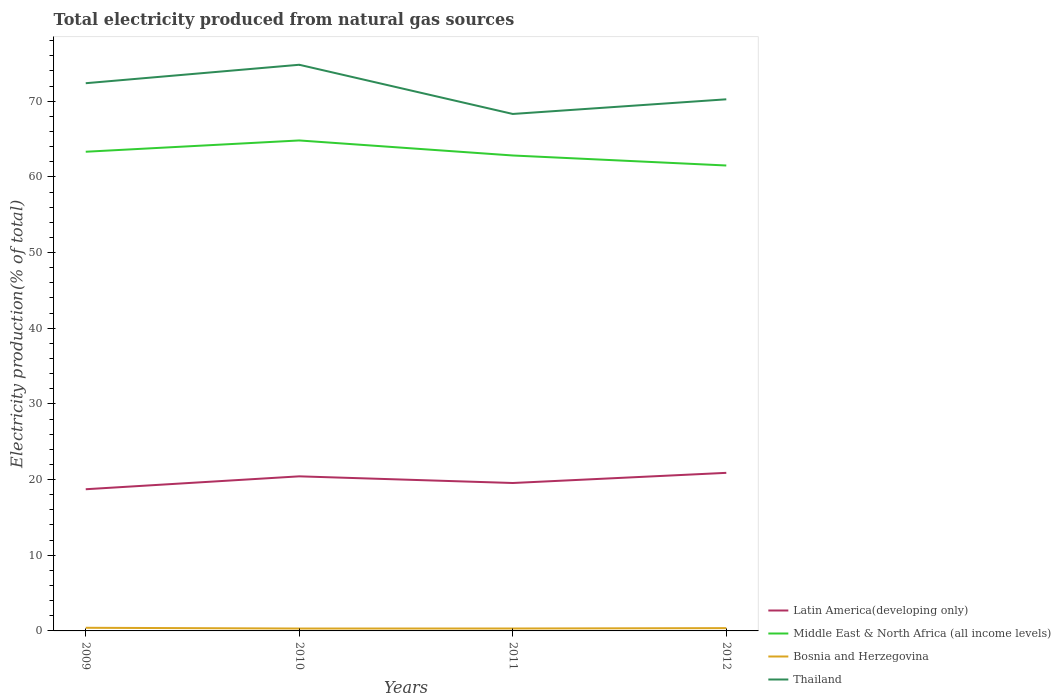How many different coloured lines are there?
Your answer should be compact. 4. Does the line corresponding to Middle East & North Africa (all income levels) intersect with the line corresponding to Latin America(developing only)?
Offer a very short reply. No. Across all years, what is the maximum total electricity produced in Latin America(developing only)?
Your answer should be very brief. 18.72. In which year was the total electricity produced in Bosnia and Herzegovina maximum?
Make the answer very short. 2010. What is the total total electricity produced in Bosnia and Herzegovina in the graph?
Provide a short and direct response. -0.05. What is the difference between the highest and the second highest total electricity produced in Latin America(developing only)?
Provide a short and direct response. 2.17. How many years are there in the graph?
Give a very brief answer. 4. What is the difference between two consecutive major ticks on the Y-axis?
Offer a very short reply. 10. Are the values on the major ticks of Y-axis written in scientific E-notation?
Keep it short and to the point. No. What is the title of the graph?
Provide a short and direct response. Total electricity produced from natural gas sources. What is the label or title of the X-axis?
Offer a terse response. Years. What is the Electricity production(% of total) of Latin America(developing only) in 2009?
Ensure brevity in your answer.  18.72. What is the Electricity production(% of total) of Middle East & North Africa (all income levels) in 2009?
Your response must be concise. 63.32. What is the Electricity production(% of total) of Bosnia and Herzegovina in 2009?
Provide a succinct answer. 0.41. What is the Electricity production(% of total) of Thailand in 2009?
Offer a very short reply. 72.38. What is the Electricity production(% of total) of Latin America(developing only) in 2010?
Offer a very short reply. 20.43. What is the Electricity production(% of total) of Middle East & North Africa (all income levels) in 2010?
Ensure brevity in your answer.  64.82. What is the Electricity production(% of total) in Bosnia and Herzegovina in 2010?
Your response must be concise. 0.32. What is the Electricity production(% of total) in Thailand in 2010?
Keep it short and to the point. 74.82. What is the Electricity production(% of total) of Latin America(developing only) in 2011?
Your answer should be compact. 19.55. What is the Electricity production(% of total) of Middle East & North Africa (all income levels) in 2011?
Make the answer very short. 62.83. What is the Electricity production(% of total) in Bosnia and Herzegovina in 2011?
Your answer should be compact. 0.32. What is the Electricity production(% of total) in Thailand in 2011?
Provide a succinct answer. 68.32. What is the Electricity production(% of total) of Latin America(developing only) in 2012?
Give a very brief answer. 20.89. What is the Electricity production(% of total) in Middle East & North Africa (all income levels) in 2012?
Ensure brevity in your answer.  61.51. What is the Electricity production(% of total) of Bosnia and Herzegovina in 2012?
Offer a terse response. 0.37. What is the Electricity production(% of total) in Thailand in 2012?
Offer a very short reply. 70.25. Across all years, what is the maximum Electricity production(% of total) in Latin America(developing only)?
Your answer should be compact. 20.89. Across all years, what is the maximum Electricity production(% of total) in Middle East & North Africa (all income levels)?
Your answer should be compact. 64.82. Across all years, what is the maximum Electricity production(% of total) in Bosnia and Herzegovina?
Your response must be concise. 0.41. Across all years, what is the maximum Electricity production(% of total) of Thailand?
Your answer should be very brief. 74.82. Across all years, what is the minimum Electricity production(% of total) in Latin America(developing only)?
Provide a short and direct response. 18.72. Across all years, what is the minimum Electricity production(% of total) in Middle East & North Africa (all income levels)?
Offer a very short reply. 61.51. Across all years, what is the minimum Electricity production(% of total) of Bosnia and Herzegovina?
Give a very brief answer. 0.32. Across all years, what is the minimum Electricity production(% of total) of Thailand?
Offer a terse response. 68.32. What is the total Electricity production(% of total) in Latin America(developing only) in the graph?
Ensure brevity in your answer.  79.59. What is the total Electricity production(% of total) in Middle East & North Africa (all income levels) in the graph?
Provide a short and direct response. 252.48. What is the total Electricity production(% of total) of Bosnia and Herzegovina in the graph?
Provide a short and direct response. 1.42. What is the total Electricity production(% of total) of Thailand in the graph?
Offer a terse response. 285.77. What is the difference between the Electricity production(% of total) in Latin America(developing only) in 2009 and that in 2010?
Your response must be concise. -1.7. What is the difference between the Electricity production(% of total) in Middle East & North Africa (all income levels) in 2009 and that in 2010?
Make the answer very short. -1.49. What is the difference between the Electricity production(% of total) in Bosnia and Herzegovina in 2009 and that in 2010?
Provide a short and direct response. 0.1. What is the difference between the Electricity production(% of total) in Thailand in 2009 and that in 2010?
Ensure brevity in your answer.  -2.44. What is the difference between the Electricity production(% of total) of Latin America(developing only) in 2009 and that in 2011?
Make the answer very short. -0.82. What is the difference between the Electricity production(% of total) in Middle East & North Africa (all income levels) in 2009 and that in 2011?
Ensure brevity in your answer.  0.49. What is the difference between the Electricity production(% of total) of Bosnia and Herzegovina in 2009 and that in 2011?
Keep it short and to the point. 0.09. What is the difference between the Electricity production(% of total) of Thailand in 2009 and that in 2011?
Your response must be concise. 4.06. What is the difference between the Electricity production(% of total) in Latin America(developing only) in 2009 and that in 2012?
Your answer should be very brief. -2.17. What is the difference between the Electricity production(% of total) of Middle East & North Africa (all income levels) in 2009 and that in 2012?
Make the answer very short. 1.82. What is the difference between the Electricity production(% of total) of Bosnia and Herzegovina in 2009 and that in 2012?
Your answer should be compact. 0.05. What is the difference between the Electricity production(% of total) in Thailand in 2009 and that in 2012?
Offer a terse response. 2.13. What is the difference between the Electricity production(% of total) in Latin America(developing only) in 2010 and that in 2011?
Offer a very short reply. 0.88. What is the difference between the Electricity production(% of total) in Middle East & North Africa (all income levels) in 2010 and that in 2011?
Provide a short and direct response. 1.99. What is the difference between the Electricity production(% of total) in Bosnia and Herzegovina in 2010 and that in 2011?
Provide a short and direct response. -0.01. What is the difference between the Electricity production(% of total) of Thailand in 2010 and that in 2011?
Your answer should be very brief. 6.5. What is the difference between the Electricity production(% of total) of Latin America(developing only) in 2010 and that in 2012?
Your answer should be very brief. -0.46. What is the difference between the Electricity production(% of total) of Middle East & North Africa (all income levels) in 2010 and that in 2012?
Your response must be concise. 3.31. What is the difference between the Electricity production(% of total) in Bosnia and Herzegovina in 2010 and that in 2012?
Offer a terse response. -0.05. What is the difference between the Electricity production(% of total) in Thailand in 2010 and that in 2012?
Make the answer very short. 4.56. What is the difference between the Electricity production(% of total) in Latin America(developing only) in 2011 and that in 2012?
Offer a terse response. -1.34. What is the difference between the Electricity production(% of total) in Middle East & North Africa (all income levels) in 2011 and that in 2012?
Your answer should be compact. 1.32. What is the difference between the Electricity production(% of total) in Bosnia and Herzegovina in 2011 and that in 2012?
Offer a very short reply. -0.05. What is the difference between the Electricity production(% of total) in Thailand in 2011 and that in 2012?
Make the answer very short. -1.94. What is the difference between the Electricity production(% of total) in Latin America(developing only) in 2009 and the Electricity production(% of total) in Middle East & North Africa (all income levels) in 2010?
Give a very brief answer. -46.09. What is the difference between the Electricity production(% of total) of Latin America(developing only) in 2009 and the Electricity production(% of total) of Bosnia and Herzegovina in 2010?
Provide a short and direct response. 18.41. What is the difference between the Electricity production(% of total) in Latin America(developing only) in 2009 and the Electricity production(% of total) in Thailand in 2010?
Your response must be concise. -56.09. What is the difference between the Electricity production(% of total) in Middle East & North Africa (all income levels) in 2009 and the Electricity production(% of total) in Bosnia and Herzegovina in 2010?
Make the answer very short. 63.01. What is the difference between the Electricity production(% of total) in Middle East & North Africa (all income levels) in 2009 and the Electricity production(% of total) in Thailand in 2010?
Your response must be concise. -11.49. What is the difference between the Electricity production(% of total) in Bosnia and Herzegovina in 2009 and the Electricity production(% of total) in Thailand in 2010?
Your answer should be compact. -74.4. What is the difference between the Electricity production(% of total) of Latin America(developing only) in 2009 and the Electricity production(% of total) of Middle East & North Africa (all income levels) in 2011?
Offer a terse response. -44.11. What is the difference between the Electricity production(% of total) of Latin America(developing only) in 2009 and the Electricity production(% of total) of Bosnia and Herzegovina in 2011?
Your response must be concise. 18.4. What is the difference between the Electricity production(% of total) in Latin America(developing only) in 2009 and the Electricity production(% of total) in Thailand in 2011?
Offer a terse response. -49.59. What is the difference between the Electricity production(% of total) in Middle East & North Africa (all income levels) in 2009 and the Electricity production(% of total) in Bosnia and Herzegovina in 2011?
Ensure brevity in your answer.  63. What is the difference between the Electricity production(% of total) in Middle East & North Africa (all income levels) in 2009 and the Electricity production(% of total) in Thailand in 2011?
Your answer should be very brief. -4.99. What is the difference between the Electricity production(% of total) in Bosnia and Herzegovina in 2009 and the Electricity production(% of total) in Thailand in 2011?
Your response must be concise. -67.9. What is the difference between the Electricity production(% of total) of Latin America(developing only) in 2009 and the Electricity production(% of total) of Middle East & North Africa (all income levels) in 2012?
Your response must be concise. -42.78. What is the difference between the Electricity production(% of total) of Latin America(developing only) in 2009 and the Electricity production(% of total) of Bosnia and Herzegovina in 2012?
Provide a short and direct response. 18.35. What is the difference between the Electricity production(% of total) in Latin America(developing only) in 2009 and the Electricity production(% of total) in Thailand in 2012?
Provide a short and direct response. -51.53. What is the difference between the Electricity production(% of total) in Middle East & North Africa (all income levels) in 2009 and the Electricity production(% of total) in Bosnia and Herzegovina in 2012?
Provide a succinct answer. 62.95. What is the difference between the Electricity production(% of total) in Middle East & North Africa (all income levels) in 2009 and the Electricity production(% of total) in Thailand in 2012?
Offer a very short reply. -6.93. What is the difference between the Electricity production(% of total) of Bosnia and Herzegovina in 2009 and the Electricity production(% of total) of Thailand in 2012?
Your response must be concise. -69.84. What is the difference between the Electricity production(% of total) in Latin America(developing only) in 2010 and the Electricity production(% of total) in Middle East & North Africa (all income levels) in 2011?
Provide a short and direct response. -42.4. What is the difference between the Electricity production(% of total) in Latin America(developing only) in 2010 and the Electricity production(% of total) in Bosnia and Herzegovina in 2011?
Your answer should be very brief. 20.11. What is the difference between the Electricity production(% of total) of Latin America(developing only) in 2010 and the Electricity production(% of total) of Thailand in 2011?
Offer a terse response. -47.89. What is the difference between the Electricity production(% of total) of Middle East & North Africa (all income levels) in 2010 and the Electricity production(% of total) of Bosnia and Herzegovina in 2011?
Your answer should be very brief. 64.5. What is the difference between the Electricity production(% of total) in Middle East & North Africa (all income levels) in 2010 and the Electricity production(% of total) in Thailand in 2011?
Your answer should be very brief. -3.5. What is the difference between the Electricity production(% of total) of Bosnia and Herzegovina in 2010 and the Electricity production(% of total) of Thailand in 2011?
Your answer should be compact. -68. What is the difference between the Electricity production(% of total) of Latin America(developing only) in 2010 and the Electricity production(% of total) of Middle East & North Africa (all income levels) in 2012?
Make the answer very short. -41.08. What is the difference between the Electricity production(% of total) of Latin America(developing only) in 2010 and the Electricity production(% of total) of Bosnia and Herzegovina in 2012?
Provide a succinct answer. 20.06. What is the difference between the Electricity production(% of total) in Latin America(developing only) in 2010 and the Electricity production(% of total) in Thailand in 2012?
Keep it short and to the point. -49.83. What is the difference between the Electricity production(% of total) in Middle East & North Africa (all income levels) in 2010 and the Electricity production(% of total) in Bosnia and Herzegovina in 2012?
Your answer should be very brief. 64.45. What is the difference between the Electricity production(% of total) of Middle East & North Africa (all income levels) in 2010 and the Electricity production(% of total) of Thailand in 2012?
Ensure brevity in your answer.  -5.44. What is the difference between the Electricity production(% of total) of Bosnia and Herzegovina in 2010 and the Electricity production(% of total) of Thailand in 2012?
Your answer should be compact. -69.94. What is the difference between the Electricity production(% of total) of Latin America(developing only) in 2011 and the Electricity production(% of total) of Middle East & North Africa (all income levels) in 2012?
Give a very brief answer. -41.96. What is the difference between the Electricity production(% of total) in Latin America(developing only) in 2011 and the Electricity production(% of total) in Bosnia and Herzegovina in 2012?
Your answer should be very brief. 19.18. What is the difference between the Electricity production(% of total) in Latin America(developing only) in 2011 and the Electricity production(% of total) in Thailand in 2012?
Offer a very short reply. -50.71. What is the difference between the Electricity production(% of total) of Middle East & North Africa (all income levels) in 2011 and the Electricity production(% of total) of Bosnia and Herzegovina in 2012?
Keep it short and to the point. 62.46. What is the difference between the Electricity production(% of total) in Middle East & North Africa (all income levels) in 2011 and the Electricity production(% of total) in Thailand in 2012?
Make the answer very short. -7.42. What is the difference between the Electricity production(% of total) in Bosnia and Herzegovina in 2011 and the Electricity production(% of total) in Thailand in 2012?
Offer a terse response. -69.93. What is the average Electricity production(% of total) in Latin America(developing only) per year?
Your answer should be compact. 19.9. What is the average Electricity production(% of total) of Middle East & North Africa (all income levels) per year?
Keep it short and to the point. 63.12. What is the average Electricity production(% of total) in Bosnia and Herzegovina per year?
Your answer should be compact. 0.35. What is the average Electricity production(% of total) of Thailand per year?
Your response must be concise. 71.44. In the year 2009, what is the difference between the Electricity production(% of total) of Latin America(developing only) and Electricity production(% of total) of Middle East & North Africa (all income levels)?
Your response must be concise. -44.6. In the year 2009, what is the difference between the Electricity production(% of total) in Latin America(developing only) and Electricity production(% of total) in Bosnia and Herzegovina?
Your response must be concise. 18.31. In the year 2009, what is the difference between the Electricity production(% of total) in Latin America(developing only) and Electricity production(% of total) in Thailand?
Offer a terse response. -53.66. In the year 2009, what is the difference between the Electricity production(% of total) in Middle East & North Africa (all income levels) and Electricity production(% of total) in Bosnia and Herzegovina?
Your response must be concise. 62.91. In the year 2009, what is the difference between the Electricity production(% of total) of Middle East & North Africa (all income levels) and Electricity production(% of total) of Thailand?
Provide a short and direct response. -9.06. In the year 2009, what is the difference between the Electricity production(% of total) in Bosnia and Herzegovina and Electricity production(% of total) in Thailand?
Your answer should be compact. -71.97. In the year 2010, what is the difference between the Electricity production(% of total) of Latin America(developing only) and Electricity production(% of total) of Middle East & North Africa (all income levels)?
Offer a very short reply. -44.39. In the year 2010, what is the difference between the Electricity production(% of total) of Latin America(developing only) and Electricity production(% of total) of Bosnia and Herzegovina?
Offer a very short reply. 20.11. In the year 2010, what is the difference between the Electricity production(% of total) in Latin America(developing only) and Electricity production(% of total) in Thailand?
Give a very brief answer. -54.39. In the year 2010, what is the difference between the Electricity production(% of total) of Middle East & North Africa (all income levels) and Electricity production(% of total) of Bosnia and Herzegovina?
Offer a very short reply. 64.5. In the year 2010, what is the difference between the Electricity production(% of total) in Middle East & North Africa (all income levels) and Electricity production(% of total) in Thailand?
Give a very brief answer. -10. In the year 2010, what is the difference between the Electricity production(% of total) of Bosnia and Herzegovina and Electricity production(% of total) of Thailand?
Give a very brief answer. -74.5. In the year 2011, what is the difference between the Electricity production(% of total) of Latin America(developing only) and Electricity production(% of total) of Middle East & North Africa (all income levels)?
Offer a very short reply. -43.28. In the year 2011, what is the difference between the Electricity production(% of total) of Latin America(developing only) and Electricity production(% of total) of Bosnia and Herzegovina?
Offer a very short reply. 19.23. In the year 2011, what is the difference between the Electricity production(% of total) in Latin America(developing only) and Electricity production(% of total) in Thailand?
Your answer should be compact. -48.77. In the year 2011, what is the difference between the Electricity production(% of total) in Middle East & North Africa (all income levels) and Electricity production(% of total) in Bosnia and Herzegovina?
Make the answer very short. 62.51. In the year 2011, what is the difference between the Electricity production(% of total) in Middle East & North Africa (all income levels) and Electricity production(% of total) in Thailand?
Provide a short and direct response. -5.49. In the year 2011, what is the difference between the Electricity production(% of total) of Bosnia and Herzegovina and Electricity production(% of total) of Thailand?
Offer a terse response. -68. In the year 2012, what is the difference between the Electricity production(% of total) of Latin America(developing only) and Electricity production(% of total) of Middle East & North Africa (all income levels)?
Your answer should be very brief. -40.62. In the year 2012, what is the difference between the Electricity production(% of total) of Latin America(developing only) and Electricity production(% of total) of Bosnia and Herzegovina?
Your response must be concise. 20.52. In the year 2012, what is the difference between the Electricity production(% of total) of Latin America(developing only) and Electricity production(% of total) of Thailand?
Give a very brief answer. -49.36. In the year 2012, what is the difference between the Electricity production(% of total) in Middle East & North Africa (all income levels) and Electricity production(% of total) in Bosnia and Herzegovina?
Your answer should be compact. 61.14. In the year 2012, what is the difference between the Electricity production(% of total) of Middle East & North Africa (all income levels) and Electricity production(% of total) of Thailand?
Offer a terse response. -8.75. In the year 2012, what is the difference between the Electricity production(% of total) of Bosnia and Herzegovina and Electricity production(% of total) of Thailand?
Give a very brief answer. -69.88. What is the ratio of the Electricity production(% of total) in Latin America(developing only) in 2009 to that in 2010?
Your answer should be compact. 0.92. What is the ratio of the Electricity production(% of total) in Bosnia and Herzegovina in 2009 to that in 2010?
Make the answer very short. 1.32. What is the ratio of the Electricity production(% of total) of Thailand in 2009 to that in 2010?
Give a very brief answer. 0.97. What is the ratio of the Electricity production(% of total) in Latin America(developing only) in 2009 to that in 2011?
Your answer should be very brief. 0.96. What is the ratio of the Electricity production(% of total) in Middle East & North Africa (all income levels) in 2009 to that in 2011?
Your answer should be compact. 1.01. What is the ratio of the Electricity production(% of total) of Bosnia and Herzegovina in 2009 to that in 2011?
Offer a very short reply. 1.29. What is the ratio of the Electricity production(% of total) of Thailand in 2009 to that in 2011?
Provide a short and direct response. 1.06. What is the ratio of the Electricity production(% of total) of Latin America(developing only) in 2009 to that in 2012?
Provide a succinct answer. 0.9. What is the ratio of the Electricity production(% of total) of Middle East & North Africa (all income levels) in 2009 to that in 2012?
Ensure brevity in your answer.  1.03. What is the ratio of the Electricity production(% of total) of Bosnia and Herzegovina in 2009 to that in 2012?
Provide a short and direct response. 1.12. What is the ratio of the Electricity production(% of total) of Thailand in 2009 to that in 2012?
Give a very brief answer. 1.03. What is the ratio of the Electricity production(% of total) in Latin America(developing only) in 2010 to that in 2011?
Give a very brief answer. 1.05. What is the ratio of the Electricity production(% of total) in Middle East & North Africa (all income levels) in 2010 to that in 2011?
Offer a terse response. 1.03. What is the ratio of the Electricity production(% of total) of Bosnia and Herzegovina in 2010 to that in 2011?
Provide a short and direct response. 0.98. What is the ratio of the Electricity production(% of total) of Thailand in 2010 to that in 2011?
Your response must be concise. 1.1. What is the ratio of the Electricity production(% of total) in Latin America(developing only) in 2010 to that in 2012?
Provide a short and direct response. 0.98. What is the ratio of the Electricity production(% of total) in Middle East & North Africa (all income levels) in 2010 to that in 2012?
Ensure brevity in your answer.  1.05. What is the ratio of the Electricity production(% of total) in Bosnia and Herzegovina in 2010 to that in 2012?
Provide a succinct answer. 0.85. What is the ratio of the Electricity production(% of total) of Thailand in 2010 to that in 2012?
Offer a very short reply. 1.06. What is the ratio of the Electricity production(% of total) of Latin America(developing only) in 2011 to that in 2012?
Make the answer very short. 0.94. What is the ratio of the Electricity production(% of total) of Middle East & North Africa (all income levels) in 2011 to that in 2012?
Your answer should be very brief. 1.02. What is the ratio of the Electricity production(% of total) of Bosnia and Herzegovina in 2011 to that in 2012?
Make the answer very short. 0.87. What is the ratio of the Electricity production(% of total) of Thailand in 2011 to that in 2012?
Make the answer very short. 0.97. What is the difference between the highest and the second highest Electricity production(% of total) in Latin America(developing only)?
Give a very brief answer. 0.46. What is the difference between the highest and the second highest Electricity production(% of total) of Middle East & North Africa (all income levels)?
Ensure brevity in your answer.  1.49. What is the difference between the highest and the second highest Electricity production(% of total) of Bosnia and Herzegovina?
Provide a succinct answer. 0.05. What is the difference between the highest and the second highest Electricity production(% of total) of Thailand?
Offer a terse response. 2.44. What is the difference between the highest and the lowest Electricity production(% of total) of Latin America(developing only)?
Offer a terse response. 2.17. What is the difference between the highest and the lowest Electricity production(% of total) in Middle East & North Africa (all income levels)?
Ensure brevity in your answer.  3.31. What is the difference between the highest and the lowest Electricity production(% of total) of Bosnia and Herzegovina?
Give a very brief answer. 0.1. What is the difference between the highest and the lowest Electricity production(% of total) of Thailand?
Offer a very short reply. 6.5. 